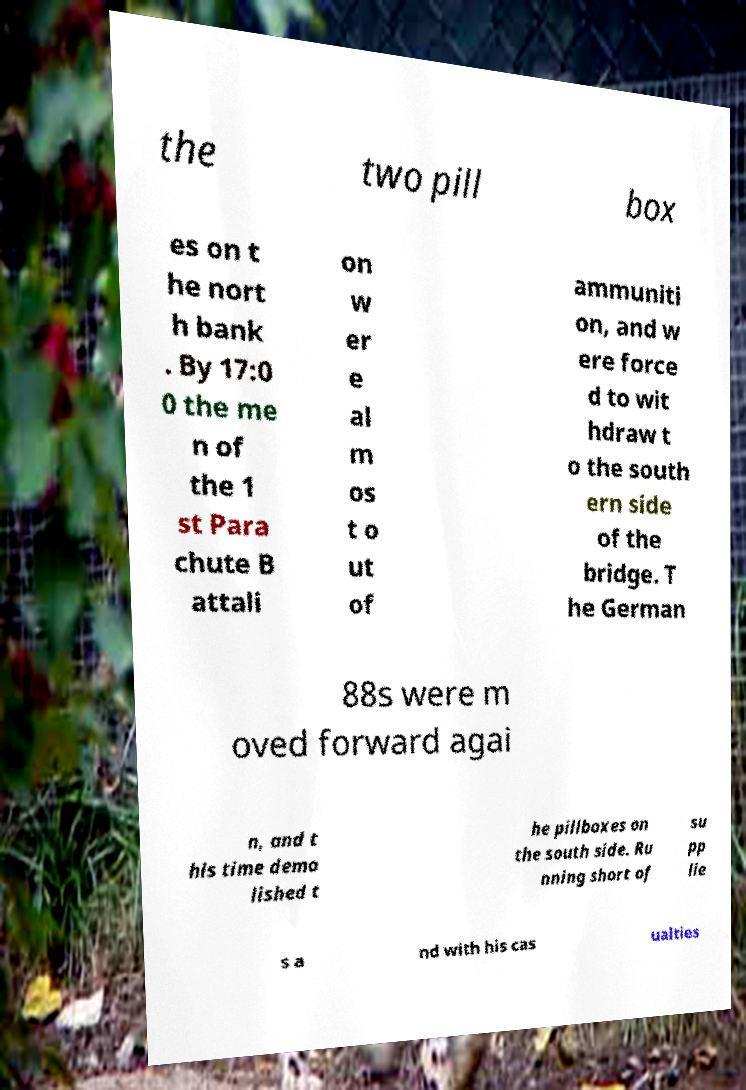Could you assist in decoding the text presented in this image and type it out clearly? the two pill box es on t he nort h bank . By 17:0 0 the me n of the 1 st Para chute B attali on w er e al m os t o ut of ammuniti on, and w ere force d to wit hdraw t o the south ern side of the bridge. T he German 88s were m oved forward agai n, and t his time demo lished t he pillboxes on the south side. Ru nning short of su pp lie s a nd with his cas ualties 